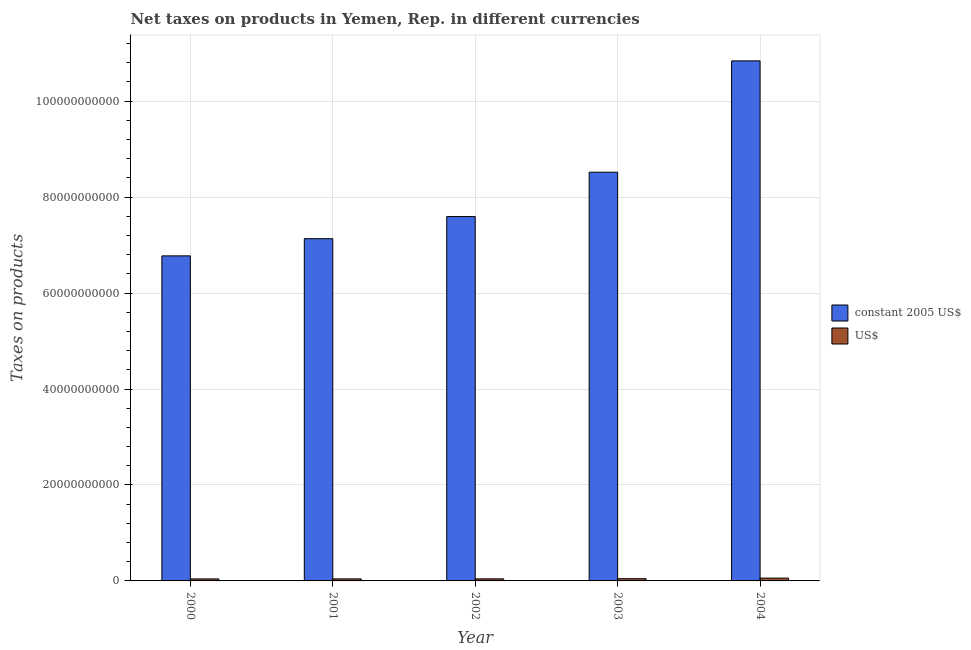How many groups of bars are there?
Your response must be concise. 5. Are the number of bars on each tick of the X-axis equal?
Make the answer very short. Yes. What is the label of the 3rd group of bars from the left?
Provide a short and direct response. 2002. What is the net taxes in us$ in 2001?
Make the answer very short. 4.23e+08. Across all years, what is the maximum net taxes in constant 2005 us$?
Provide a short and direct response. 1.08e+11. Across all years, what is the minimum net taxes in constant 2005 us$?
Your response must be concise. 6.77e+1. In which year was the net taxes in constant 2005 us$ minimum?
Provide a short and direct response. 2000. What is the total net taxes in constant 2005 us$ in the graph?
Keep it short and to the point. 4.09e+11. What is the difference between the net taxes in us$ in 2000 and that in 2001?
Give a very brief answer. -3.95e+06. What is the difference between the net taxes in constant 2005 us$ in 2001 and the net taxes in us$ in 2002?
Offer a very short reply. -4.61e+09. What is the average net taxes in constant 2005 us$ per year?
Provide a short and direct response. 8.17e+1. In the year 2000, what is the difference between the net taxes in constant 2005 us$ and net taxes in us$?
Provide a succinct answer. 0. In how many years, is the net taxes in constant 2005 us$ greater than 36000000000 units?
Provide a short and direct response. 5. What is the ratio of the net taxes in constant 2005 us$ in 2002 to that in 2004?
Keep it short and to the point. 0.7. Is the difference between the net taxes in us$ in 2002 and 2003 greater than the difference between the net taxes in constant 2005 us$ in 2002 and 2003?
Make the answer very short. No. What is the difference between the highest and the second highest net taxes in us$?
Offer a very short reply. 1.22e+08. What is the difference between the highest and the lowest net taxes in us$?
Your answer should be compact. 1.68e+08. In how many years, is the net taxes in constant 2005 us$ greater than the average net taxes in constant 2005 us$ taken over all years?
Give a very brief answer. 2. What does the 2nd bar from the left in 2001 represents?
Keep it short and to the point. US$. What does the 1st bar from the right in 2003 represents?
Offer a very short reply. US$. Are the values on the major ticks of Y-axis written in scientific E-notation?
Provide a succinct answer. No. Does the graph contain any zero values?
Make the answer very short. No. Does the graph contain grids?
Provide a succinct answer. Yes. Where does the legend appear in the graph?
Offer a terse response. Center right. How are the legend labels stacked?
Ensure brevity in your answer.  Vertical. What is the title of the graph?
Provide a short and direct response. Net taxes on products in Yemen, Rep. in different currencies. What is the label or title of the Y-axis?
Provide a short and direct response. Taxes on products. What is the Taxes on products of constant 2005 US$ in 2000?
Ensure brevity in your answer.  6.77e+1. What is the Taxes on products of US$ in 2000?
Provide a short and direct response. 4.19e+08. What is the Taxes on products of constant 2005 US$ in 2001?
Offer a terse response. 7.13e+1. What is the Taxes on products of US$ in 2001?
Your response must be concise. 4.23e+08. What is the Taxes on products of constant 2005 US$ in 2002?
Your answer should be very brief. 7.59e+1. What is the Taxes on products in US$ in 2002?
Your answer should be very brief. 4.32e+08. What is the Taxes on products in constant 2005 US$ in 2003?
Give a very brief answer. 8.52e+1. What is the Taxes on products of US$ in 2003?
Make the answer very short. 4.64e+08. What is the Taxes on products in constant 2005 US$ in 2004?
Offer a terse response. 1.08e+11. What is the Taxes on products in US$ in 2004?
Offer a very short reply. 5.87e+08. Across all years, what is the maximum Taxes on products of constant 2005 US$?
Make the answer very short. 1.08e+11. Across all years, what is the maximum Taxes on products in US$?
Ensure brevity in your answer.  5.87e+08. Across all years, what is the minimum Taxes on products of constant 2005 US$?
Ensure brevity in your answer.  6.77e+1. Across all years, what is the minimum Taxes on products in US$?
Make the answer very short. 4.19e+08. What is the total Taxes on products of constant 2005 US$ in the graph?
Provide a short and direct response. 4.09e+11. What is the total Taxes on products of US$ in the graph?
Your response must be concise. 2.33e+09. What is the difference between the Taxes on products of constant 2005 US$ in 2000 and that in 2001?
Give a very brief answer. -3.58e+09. What is the difference between the Taxes on products of US$ in 2000 and that in 2001?
Give a very brief answer. -3.95e+06. What is the difference between the Taxes on products in constant 2005 US$ in 2000 and that in 2002?
Ensure brevity in your answer.  -8.19e+09. What is the difference between the Taxes on products of US$ in 2000 and that in 2002?
Make the answer very short. -1.35e+07. What is the difference between the Taxes on products in constant 2005 US$ in 2000 and that in 2003?
Your answer should be very brief. -1.74e+1. What is the difference between the Taxes on products of US$ in 2000 and that in 2003?
Offer a terse response. -4.54e+07. What is the difference between the Taxes on products of constant 2005 US$ in 2000 and that in 2004?
Keep it short and to the point. -4.06e+1. What is the difference between the Taxes on products in US$ in 2000 and that in 2004?
Your response must be concise. -1.68e+08. What is the difference between the Taxes on products in constant 2005 US$ in 2001 and that in 2002?
Your answer should be very brief. -4.61e+09. What is the difference between the Taxes on products in US$ in 2001 and that in 2002?
Make the answer very short. -9.52e+06. What is the difference between the Taxes on products in constant 2005 US$ in 2001 and that in 2003?
Provide a succinct answer. -1.39e+1. What is the difference between the Taxes on products in US$ in 2001 and that in 2003?
Your response must be concise. -4.15e+07. What is the difference between the Taxes on products in constant 2005 US$ in 2001 and that in 2004?
Ensure brevity in your answer.  -3.71e+1. What is the difference between the Taxes on products of US$ in 2001 and that in 2004?
Make the answer very short. -1.64e+08. What is the difference between the Taxes on products of constant 2005 US$ in 2002 and that in 2003?
Provide a short and direct response. -9.24e+09. What is the difference between the Taxes on products of US$ in 2002 and that in 2003?
Make the answer very short. -3.20e+07. What is the difference between the Taxes on products in constant 2005 US$ in 2002 and that in 2004?
Offer a very short reply. -3.24e+1. What is the difference between the Taxes on products of US$ in 2002 and that in 2004?
Offer a very short reply. -1.54e+08. What is the difference between the Taxes on products in constant 2005 US$ in 2003 and that in 2004?
Your answer should be very brief. -2.32e+1. What is the difference between the Taxes on products in US$ in 2003 and that in 2004?
Provide a short and direct response. -1.22e+08. What is the difference between the Taxes on products of constant 2005 US$ in 2000 and the Taxes on products of US$ in 2001?
Ensure brevity in your answer.  6.73e+1. What is the difference between the Taxes on products of constant 2005 US$ in 2000 and the Taxes on products of US$ in 2002?
Ensure brevity in your answer.  6.73e+1. What is the difference between the Taxes on products in constant 2005 US$ in 2000 and the Taxes on products in US$ in 2003?
Give a very brief answer. 6.73e+1. What is the difference between the Taxes on products of constant 2005 US$ in 2000 and the Taxes on products of US$ in 2004?
Make the answer very short. 6.72e+1. What is the difference between the Taxes on products of constant 2005 US$ in 2001 and the Taxes on products of US$ in 2002?
Keep it short and to the point. 7.09e+1. What is the difference between the Taxes on products in constant 2005 US$ in 2001 and the Taxes on products in US$ in 2003?
Offer a terse response. 7.09e+1. What is the difference between the Taxes on products of constant 2005 US$ in 2001 and the Taxes on products of US$ in 2004?
Give a very brief answer. 7.07e+1. What is the difference between the Taxes on products of constant 2005 US$ in 2002 and the Taxes on products of US$ in 2003?
Your answer should be compact. 7.55e+1. What is the difference between the Taxes on products of constant 2005 US$ in 2002 and the Taxes on products of US$ in 2004?
Your answer should be compact. 7.54e+1. What is the difference between the Taxes on products in constant 2005 US$ in 2003 and the Taxes on products in US$ in 2004?
Give a very brief answer. 8.46e+1. What is the average Taxes on products of constant 2005 US$ per year?
Provide a succinct answer. 8.17e+1. What is the average Taxes on products of US$ per year?
Make the answer very short. 4.65e+08. In the year 2000, what is the difference between the Taxes on products in constant 2005 US$ and Taxes on products in US$?
Ensure brevity in your answer.  6.73e+1. In the year 2001, what is the difference between the Taxes on products in constant 2005 US$ and Taxes on products in US$?
Provide a succinct answer. 7.09e+1. In the year 2002, what is the difference between the Taxes on products in constant 2005 US$ and Taxes on products in US$?
Provide a succinct answer. 7.55e+1. In the year 2003, what is the difference between the Taxes on products of constant 2005 US$ and Taxes on products of US$?
Make the answer very short. 8.47e+1. In the year 2004, what is the difference between the Taxes on products of constant 2005 US$ and Taxes on products of US$?
Provide a short and direct response. 1.08e+11. What is the ratio of the Taxes on products in constant 2005 US$ in 2000 to that in 2001?
Provide a short and direct response. 0.95. What is the ratio of the Taxes on products of constant 2005 US$ in 2000 to that in 2002?
Provide a succinct answer. 0.89. What is the ratio of the Taxes on products of US$ in 2000 to that in 2002?
Offer a terse response. 0.97. What is the ratio of the Taxes on products in constant 2005 US$ in 2000 to that in 2003?
Give a very brief answer. 0.8. What is the ratio of the Taxes on products of US$ in 2000 to that in 2003?
Offer a terse response. 0.9. What is the ratio of the Taxes on products in constant 2005 US$ in 2000 to that in 2004?
Your response must be concise. 0.63. What is the ratio of the Taxes on products in US$ in 2000 to that in 2004?
Provide a succinct answer. 0.71. What is the ratio of the Taxes on products in constant 2005 US$ in 2001 to that in 2002?
Your answer should be very brief. 0.94. What is the ratio of the Taxes on products in US$ in 2001 to that in 2002?
Give a very brief answer. 0.98. What is the ratio of the Taxes on products of constant 2005 US$ in 2001 to that in 2003?
Your response must be concise. 0.84. What is the ratio of the Taxes on products of US$ in 2001 to that in 2003?
Ensure brevity in your answer.  0.91. What is the ratio of the Taxes on products in constant 2005 US$ in 2001 to that in 2004?
Offer a terse response. 0.66. What is the ratio of the Taxes on products in US$ in 2001 to that in 2004?
Ensure brevity in your answer.  0.72. What is the ratio of the Taxes on products in constant 2005 US$ in 2002 to that in 2003?
Provide a short and direct response. 0.89. What is the ratio of the Taxes on products of US$ in 2002 to that in 2003?
Your answer should be compact. 0.93. What is the ratio of the Taxes on products of constant 2005 US$ in 2002 to that in 2004?
Your answer should be very brief. 0.7. What is the ratio of the Taxes on products in US$ in 2002 to that in 2004?
Ensure brevity in your answer.  0.74. What is the ratio of the Taxes on products of constant 2005 US$ in 2003 to that in 2004?
Offer a very short reply. 0.79. What is the ratio of the Taxes on products of US$ in 2003 to that in 2004?
Ensure brevity in your answer.  0.79. What is the difference between the highest and the second highest Taxes on products of constant 2005 US$?
Ensure brevity in your answer.  2.32e+1. What is the difference between the highest and the second highest Taxes on products of US$?
Ensure brevity in your answer.  1.22e+08. What is the difference between the highest and the lowest Taxes on products in constant 2005 US$?
Ensure brevity in your answer.  4.06e+1. What is the difference between the highest and the lowest Taxes on products of US$?
Your response must be concise. 1.68e+08. 